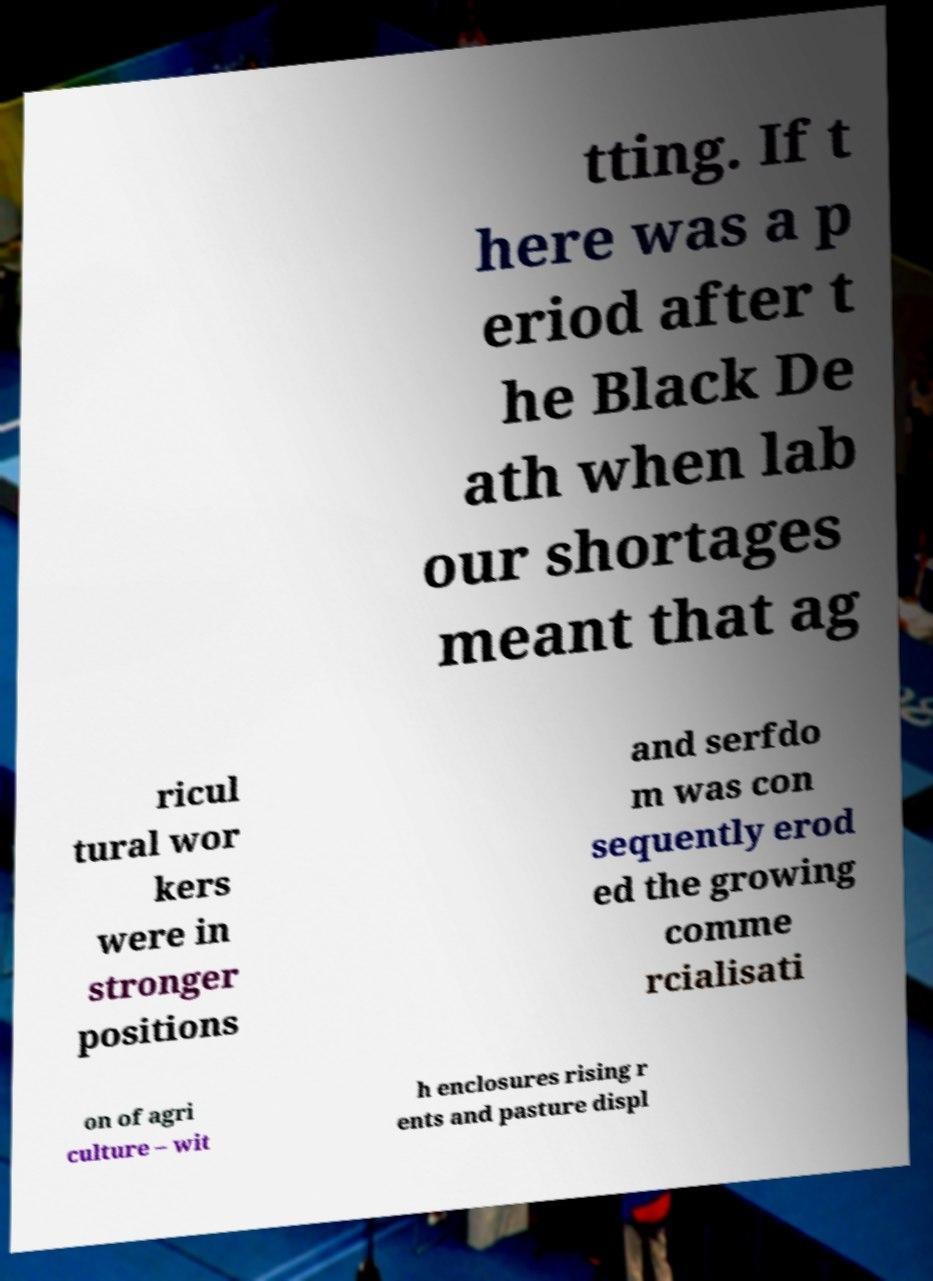For documentation purposes, I need the text within this image transcribed. Could you provide that? tting. If t here was a p eriod after t he Black De ath when lab our shortages meant that ag ricul tural wor kers were in stronger positions and serfdo m was con sequently erod ed the growing comme rcialisati on of agri culture – wit h enclosures rising r ents and pasture displ 